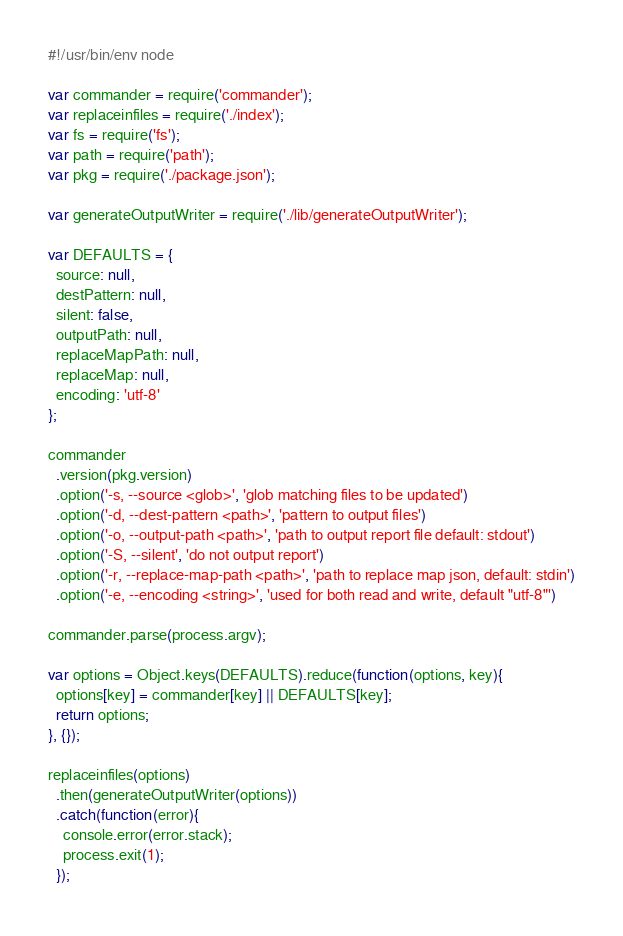Convert code to text. <code><loc_0><loc_0><loc_500><loc_500><_JavaScript_>#!/usr/bin/env node

var commander = require('commander');
var replaceinfiles = require('./index');
var fs = require('fs');
var path = require('path');
var pkg = require('./package.json');

var generateOutputWriter = require('./lib/generateOutputWriter');

var DEFAULTS = {
  source: null,
  destPattern: null,
  silent: false,
  outputPath: null,
  replaceMapPath: null,
  replaceMap: null,
  encoding: 'utf-8'
};

commander
  .version(pkg.version)
  .option('-s, --source <glob>', 'glob matching files to be updated')
  .option('-d, --dest-pattern <path>', 'pattern to output files')
  .option('-o, --output-path <path>', 'path to output report file default: stdout')
  .option('-S, --silent', 'do not output report')
  .option('-r, --replace-map-path <path>', 'path to replace map json, default: stdin')
  .option('-e, --encoding <string>', 'used for both read and write, default "utf-8"')

commander.parse(process.argv);

var options = Object.keys(DEFAULTS).reduce(function(options, key){
  options[key] = commander[key] || DEFAULTS[key];
  return options;
}, {});

replaceinfiles(options)
  .then(generateOutputWriter(options))
  .catch(function(error){
    console.error(error.stack);
    process.exit(1);
  });
</code> 